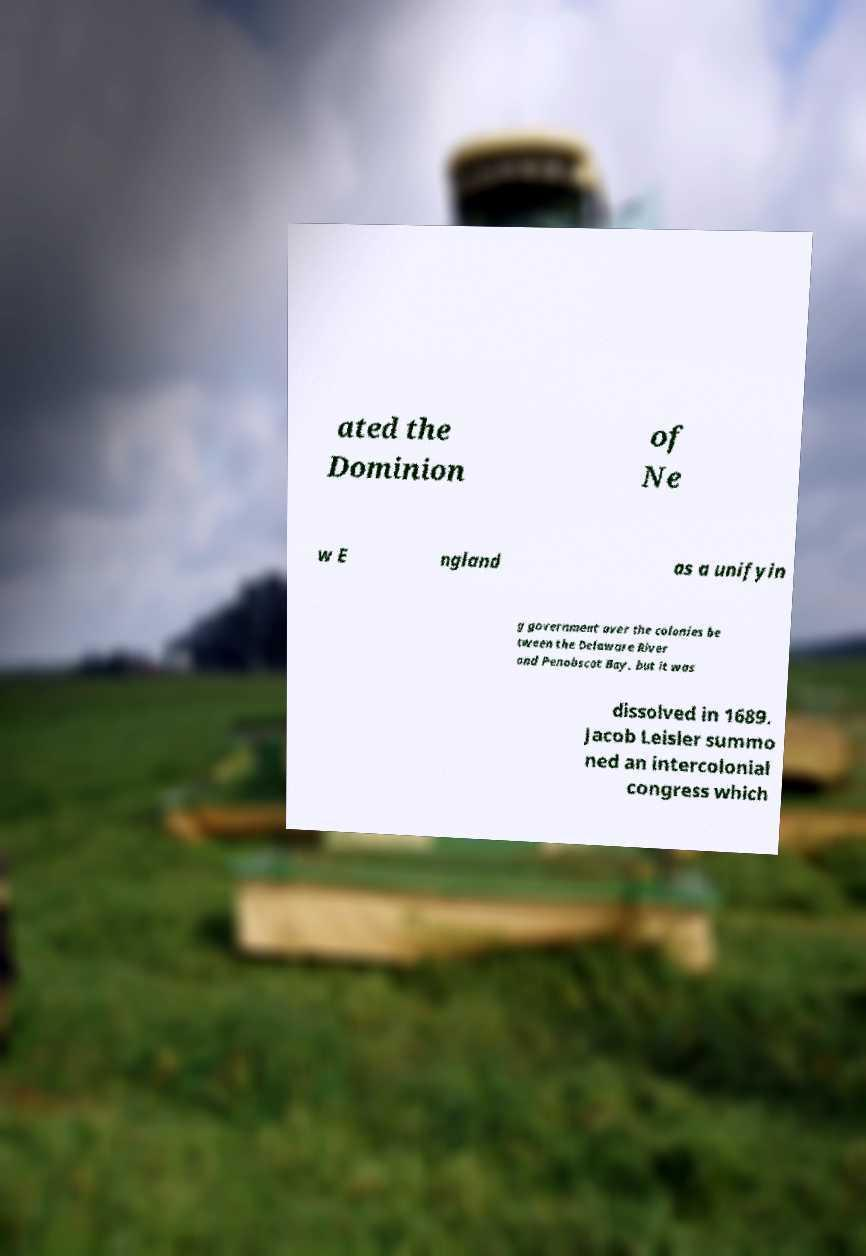Can you accurately transcribe the text from the provided image for me? ated the Dominion of Ne w E ngland as a unifyin g government over the colonies be tween the Delaware River and Penobscot Bay, but it was dissolved in 1689. Jacob Leisler summo ned an intercolonial congress which 